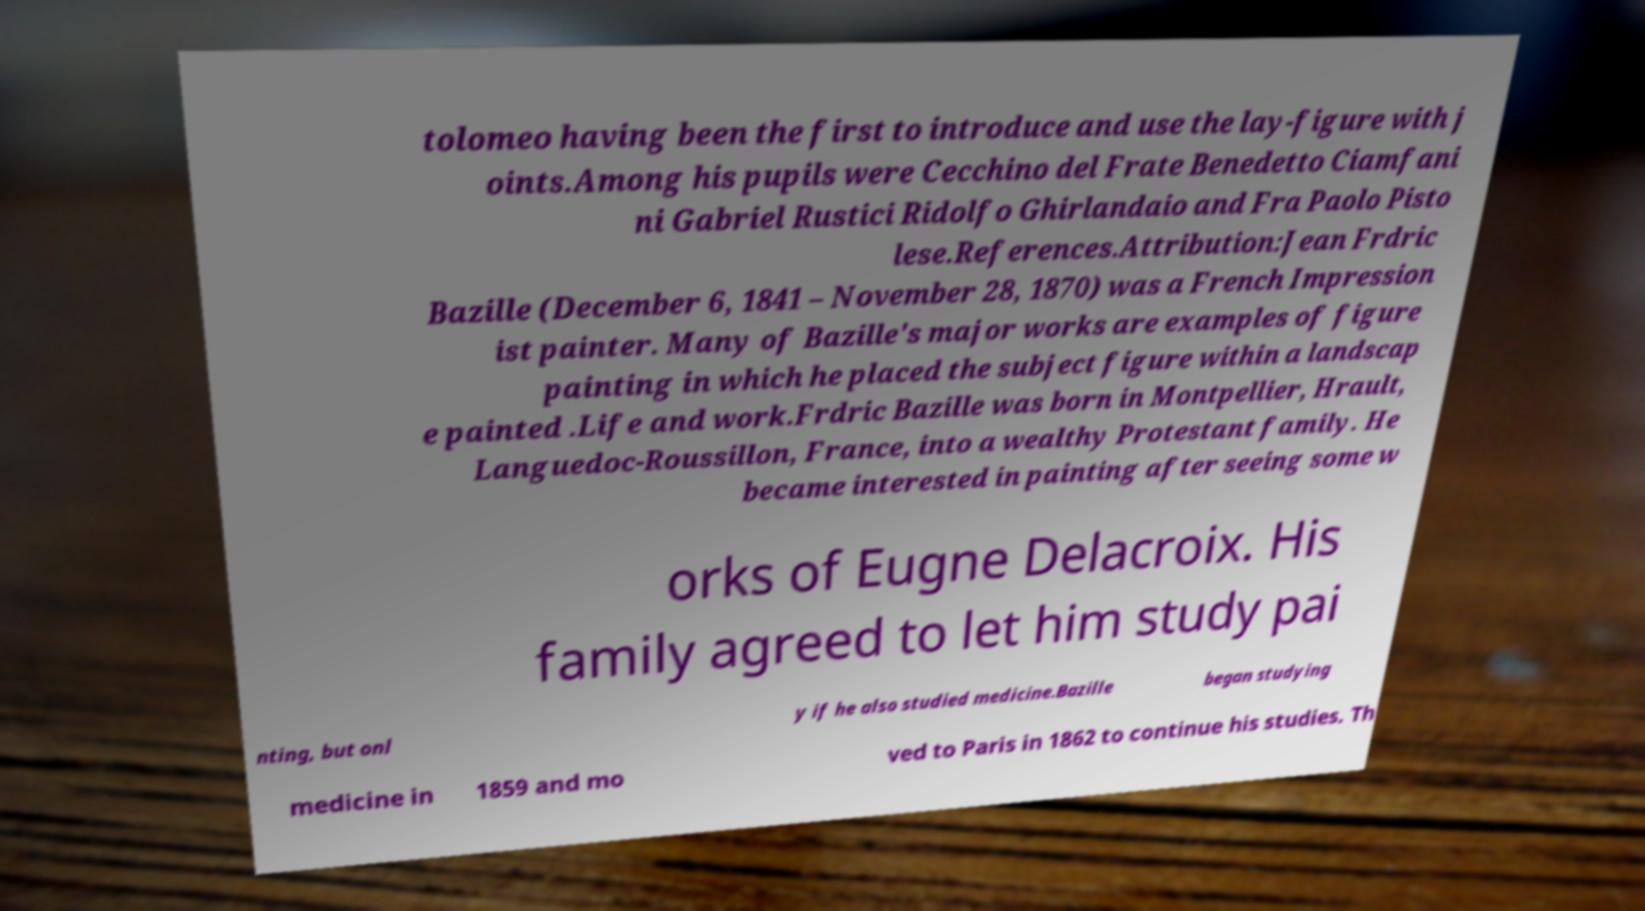Could you assist in decoding the text presented in this image and type it out clearly? tolomeo having been the first to introduce and use the lay-figure with j oints.Among his pupils were Cecchino del Frate Benedetto Ciamfani ni Gabriel Rustici Ridolfo Ghirlandaio and Fra Paolo Pisto lese.References.Attribution:Jean Frdric Bazille (December 6, 1841 – November 28, 1870) was a French Impression ist painter. Many of Bazille's major works are examples of figure painting in which he placed the subject figure within a landscap e painted .Life and work.Frdric Bazille was born in Montpellier, Hrault, Languedoc-Roussillon, France, into a wealthy Protestant family. He became interested in painting after seeing some w orks of Eugne Delacroix. His family agreed to let him study pai nting, but onl y if he also studied medicine.Bazille began studying medicine in 1859 and mo ved to Paris in 1862 to continue his studies. Th 